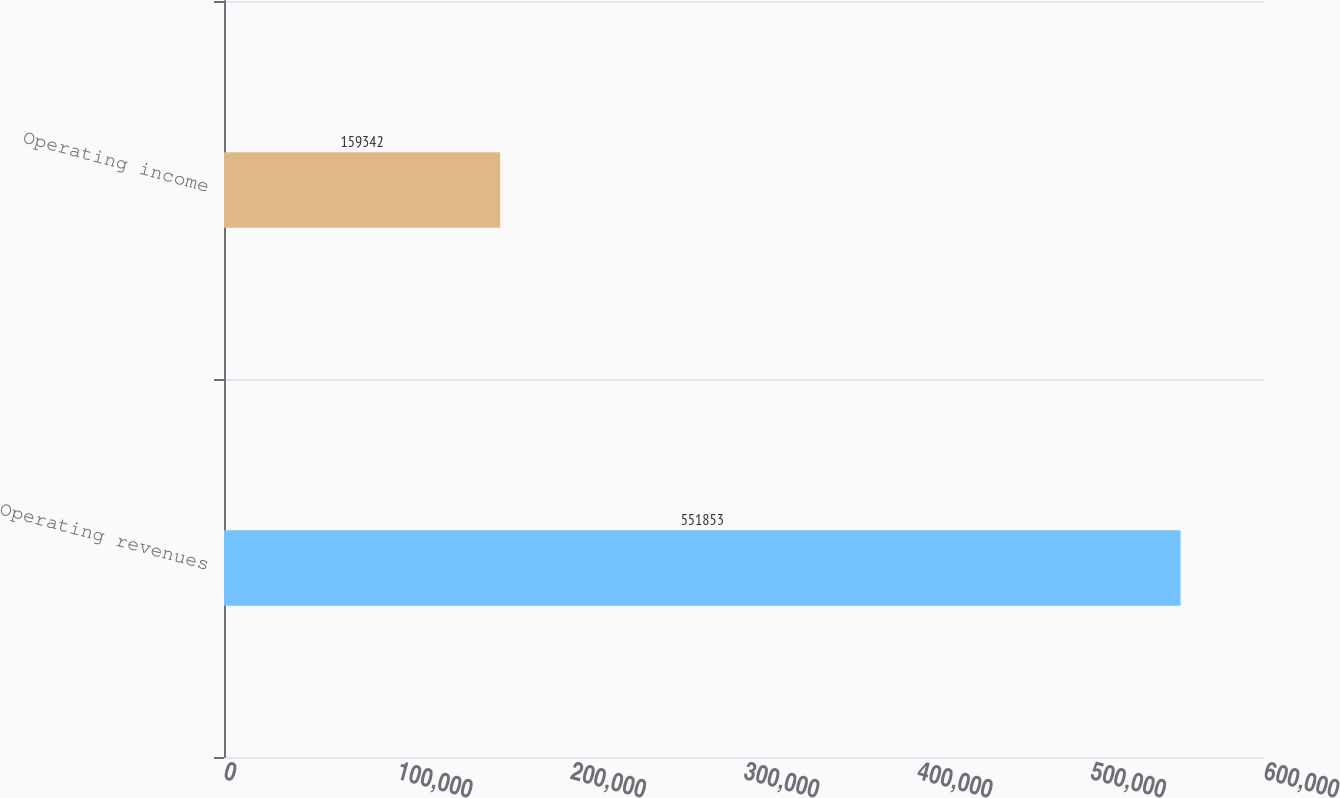Convert chart. <chart><loc_0><loc_0><loc_500><loc_500><bar_chart><fcel>Operating revenues<fcel>Operating income<nl><fcel>551853<fcel>159342<nl></chart> 